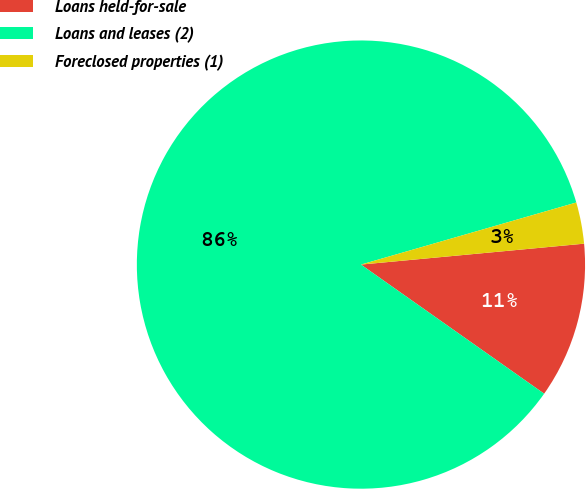Convert chart. <chart><loc_0><loc_0><loc_500><loc_500><pie_chart><fcel>Loans held-for-sale<fcel>Loans and leases (2)<fcel>Foreclosed properties (1)<nl><fcel>11.26%<fcel>85.77%<fcel>2.98%<nl></chart> 